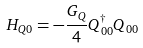Convert formula to latex. <formula><loc_0><loc_0><loc_500><loc_500>H _ { Q 0 } = - \frac { G _ { Q } } { 4 } Q _ { 0 0 } ^ { \dagger } Q _ { 0 0 }</formula> 